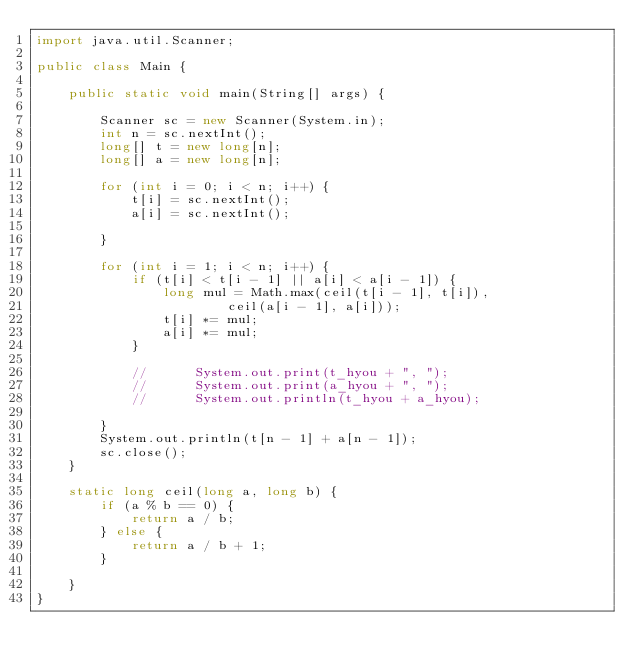Convert code to text. <code><loc_0><loc_0><loc_500><loc_500><_Java_>import java.util.Scanner;

public class Main {

	public static void main(String[] args) {

		Scanner sc = new Scanner(System.in);
		int n = sc.nextInt();
		long[] t = new long[n];
		long[] a = new long[n];

		for (int i = 0; i < n; i++) {
			t[i] = sc.nextInt();
			a[i] = sc.nextInt();

		}

		for (int i = 1; i < n; i++) {
			if (t[i] < t[i - 1] || a[i] < a[i - 1]) {
				long mul = Math.max(ceil(t[i - 1], t[i]),
						ceil(a[i - 1], a[i]));
				t[i] *= mul;
				a[i] *= mul;
			}

			//		System.out.print(t_hyou + ", ");
			//		System.out.print(a_hyou + ", ");
			//		System.out.println(t_hyou + a_hyou);

		}
		System.out.println(t[n - 1] + a[n - 1]);
		sc.close();
	}

	static long ceil(long a, long b) {
		if (a % b == 0) {
			return a / b;
		} else {
			return a / b + 1;
		}

	}
}</code> 